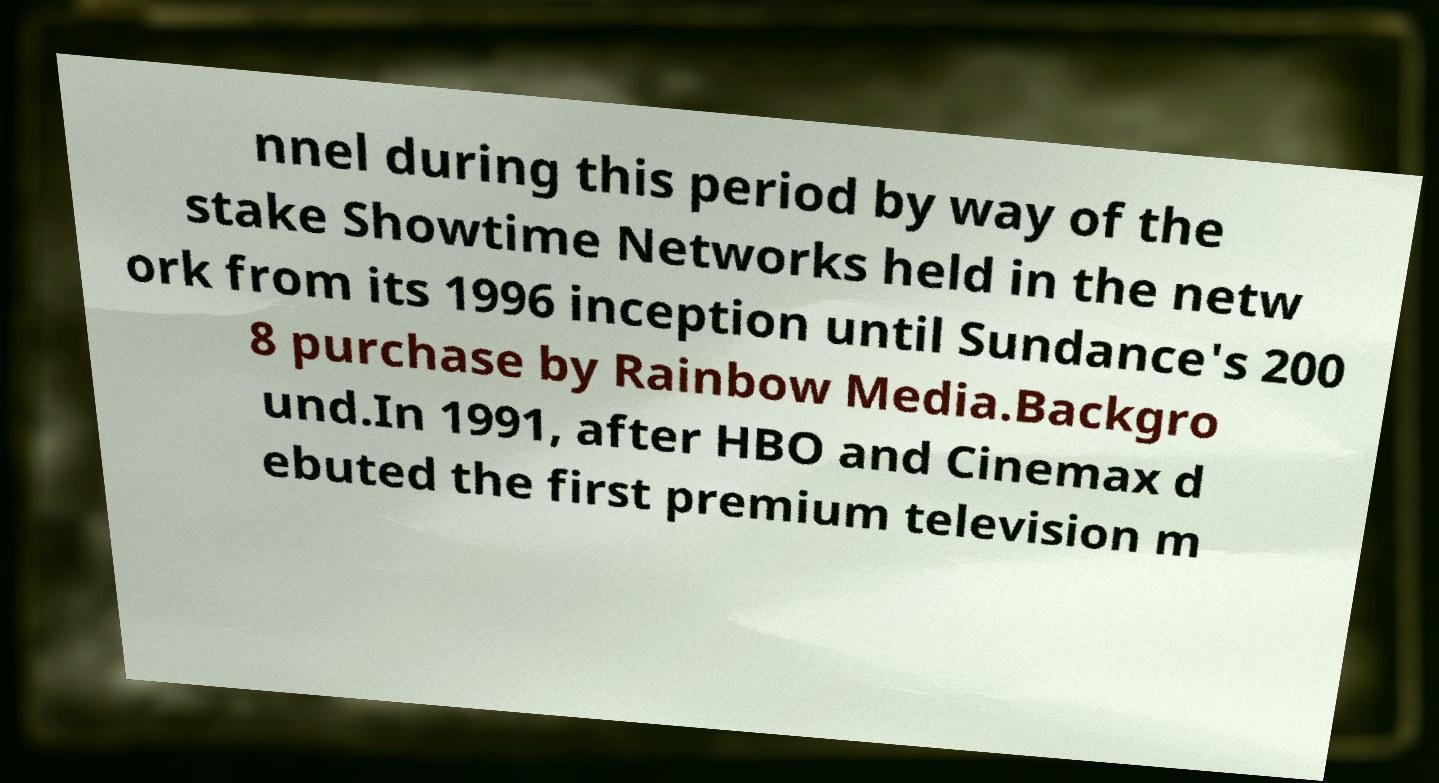What messages or text are displayed in this image? I need them in a readable, typed format. nnel during this period by way of the stake Showtime Networks held in the netw ork from its 1996 inception until Sundance's 200 8 purchase by Rainbow Media.Backgro und.In 1991, after HBO and Cinemax d ebuted the first premium television m 